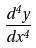Convert formula to latex. <formula><loc_0><loc_0><loc_500><loc_500>\frac { d ^ { 4 } y } { d x ^ { 4 } }</formula> 